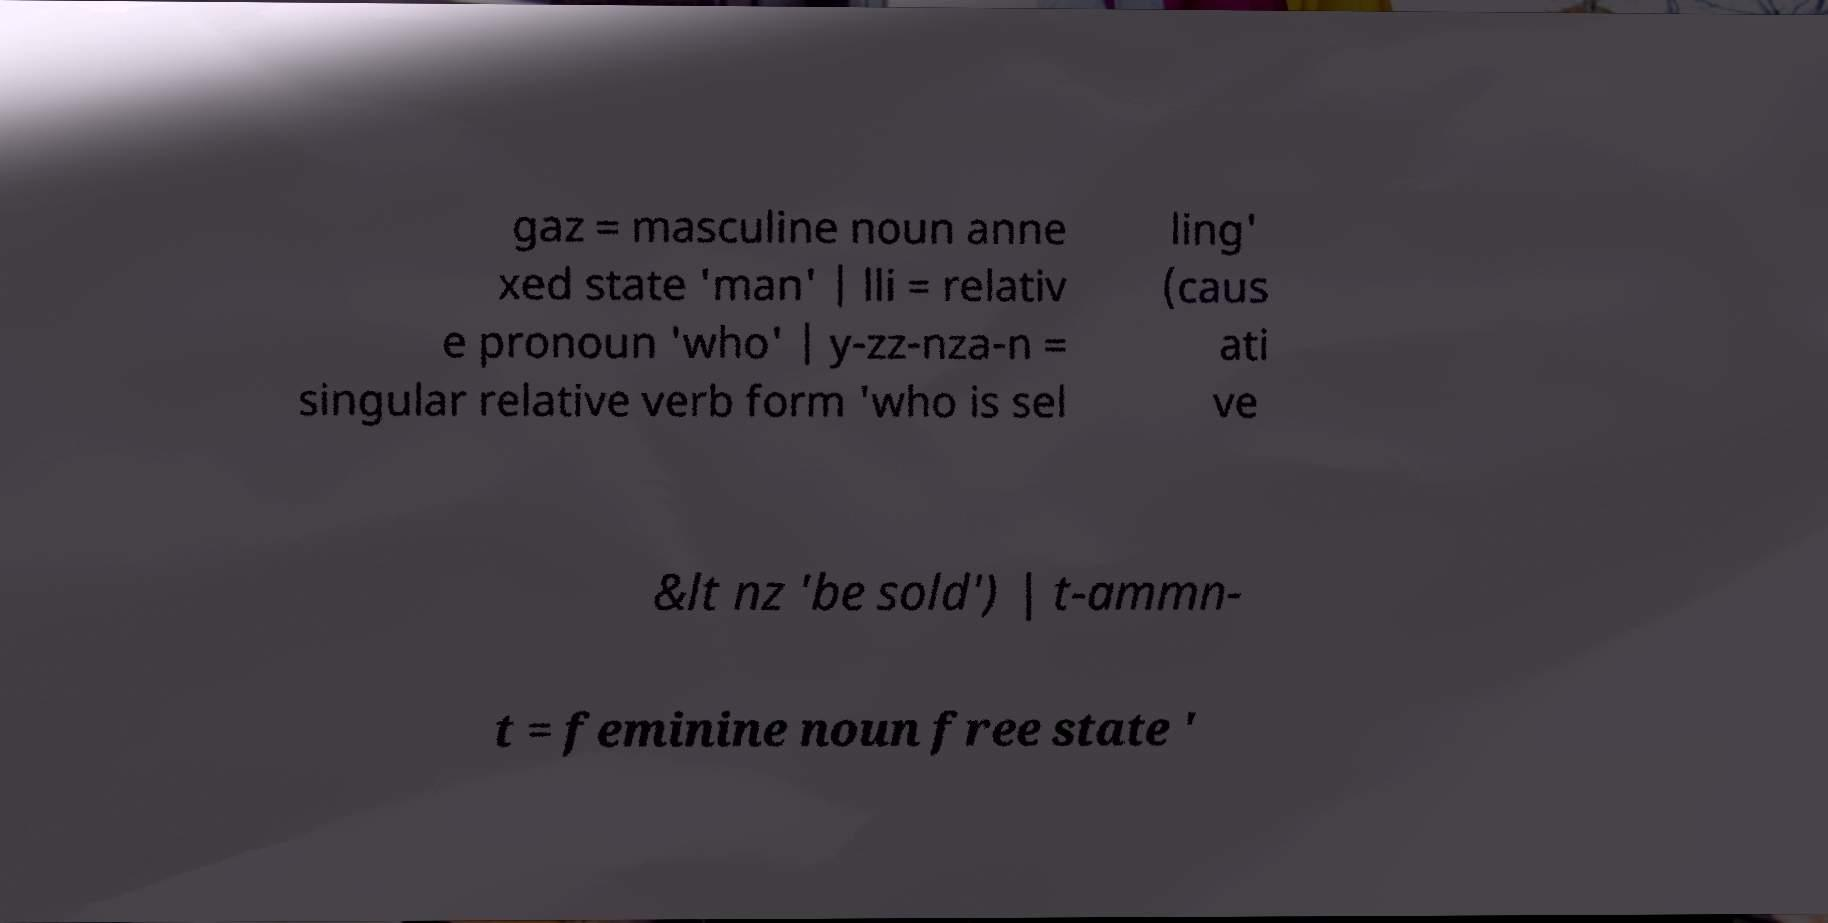Please read and relay the text visible in this image. What does it say? gaz = masculine noun anne xed state 'man' | lli = relativ e pronoun 'who' | y-zz-nza-n = singular relative verb form 'who is sel ling' (caus ati ve &lt nz 'be sold') | t-ammn- t = feminine noun free state ' 